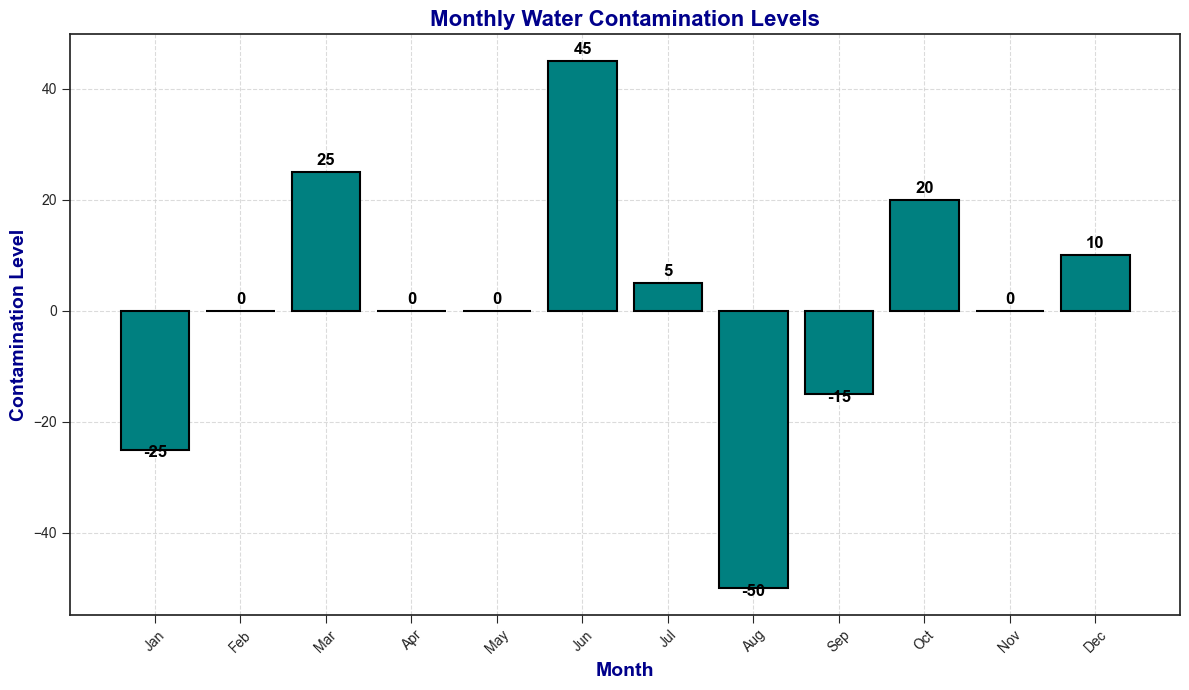What's the highest contamination level recorded in any month? By visually examining the heights of the bars, we can determine that the tallest bar represents the highest contamination level. The bar for July (the second instance) reaches a peak level of 30, which is the highest contamination level in the data.
Answer: 30 Which month has the lowest contamination level? By identifying the shortest bar in the chart, we can determine that August (the second instance) has the lowest contamination level. The bar for this month drops to -30, representing the lowest contamination level recorded.
Answer: -30 What is the average contamination level for the months of January and February? First, find the contamination values for January (-20, -5) and February (-15, 15). Combine these to get the total contamination: -20 + -5 + -15 + 15 = -25. There are 4 data points, so the average is -25/4 = -6.25
Answer: -6.25 In which month(s) does the contamination level switch from negative to positive values or vice versa? Observe the months where the bar height crosses the x-axis. For instance, from February (-15) to March (5) and from March (20) to April (-10), the values switch between negative and positive. Similar changes happen as well between June (25) and July (-25).
Answer: February-March, March-April, June-July Which months have contamination levels that are exactly equal? Examine the figure for bars with the same height. Both May (first instance) and November (second instance) have bars annotated with a 15 contamination level but distinguishable by different height or orientations can be ignored. Thus, March (second instance) and November (first instance) both have contamination levels of 10.
Answer: March (second instance) and November (first instance) What's the difference between the highest positive contamination level and the lowest negative contamination level? Identify the highest bar above the x-axis (July, second instance, 30) and the lowest bar below the x-axis (August, second instance, -30). Calculate the difference: 30 - (-30) = 60.
Answer: 60 Which month has the highest contamination level among those that have positive values? Identify all months with bars above the x-axis. The month with the highest bar among these is again July (second instance) with a contamination level of 30.
Answer: July (second instance) How many months have contamination levels that are below zero? Count the bars that fall below the x-axis. There are 7 bars with negative contamination levels: January (-20), February (-15), July (-25), August (-30), November (-10), April (-10), August (second instance, -20).
Answer: 7 